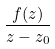Convert formula to latex. <formula><loc_0><loc_0><loc_500><loc_500>\frac { f ( z ) } { z - z _ { 0 } }</formula> 